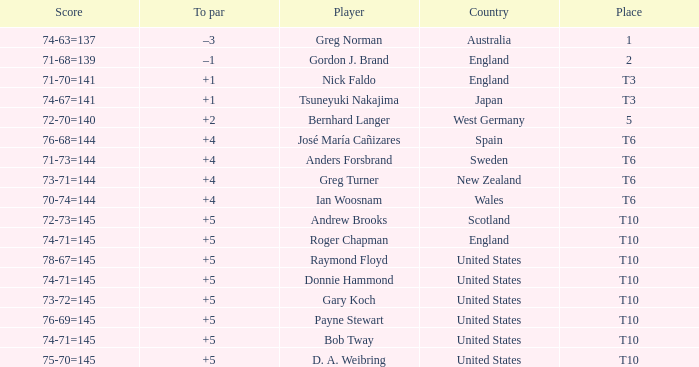What was Anders Forsbrand's score when the TO par is +4? 71-73=144. 